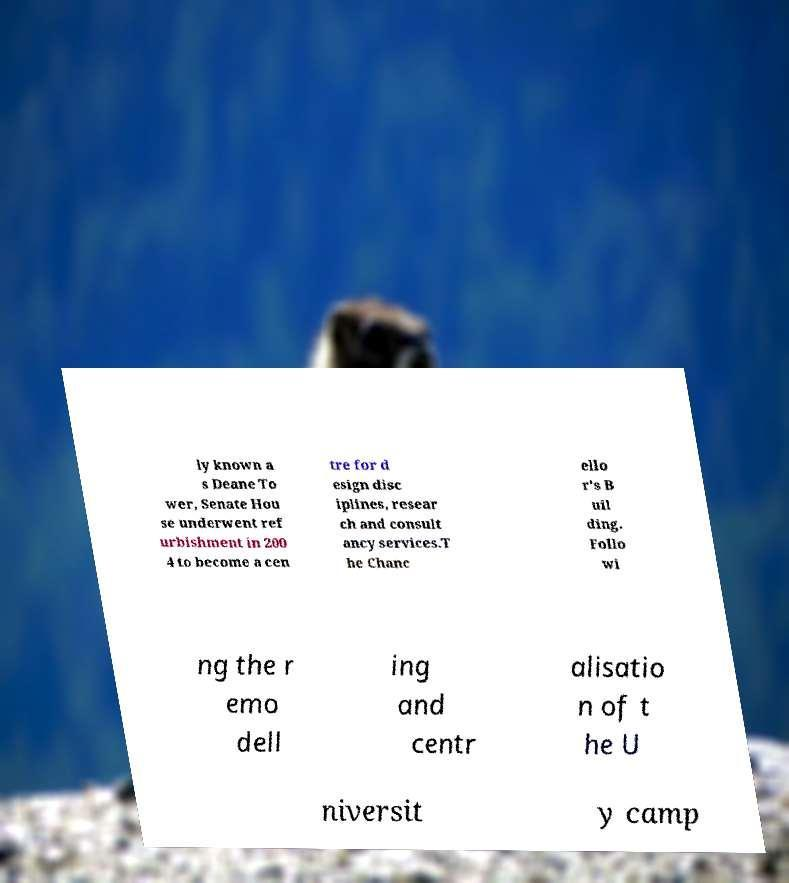Can you read and provide the text displayed in the image?This photo seems to have some interesting text. Can you extract and type it out for me? ly known a s Deane To wer, Senate Hou se underwent ref urbishment in 200 4 to become a cen tre for d esign disc iplines, resear ch and consult ancy services.T he Chanc ello r's B uil ding. Follo wi ng the r emo dell ing and centr alisatio n of t he U niversit y camp 